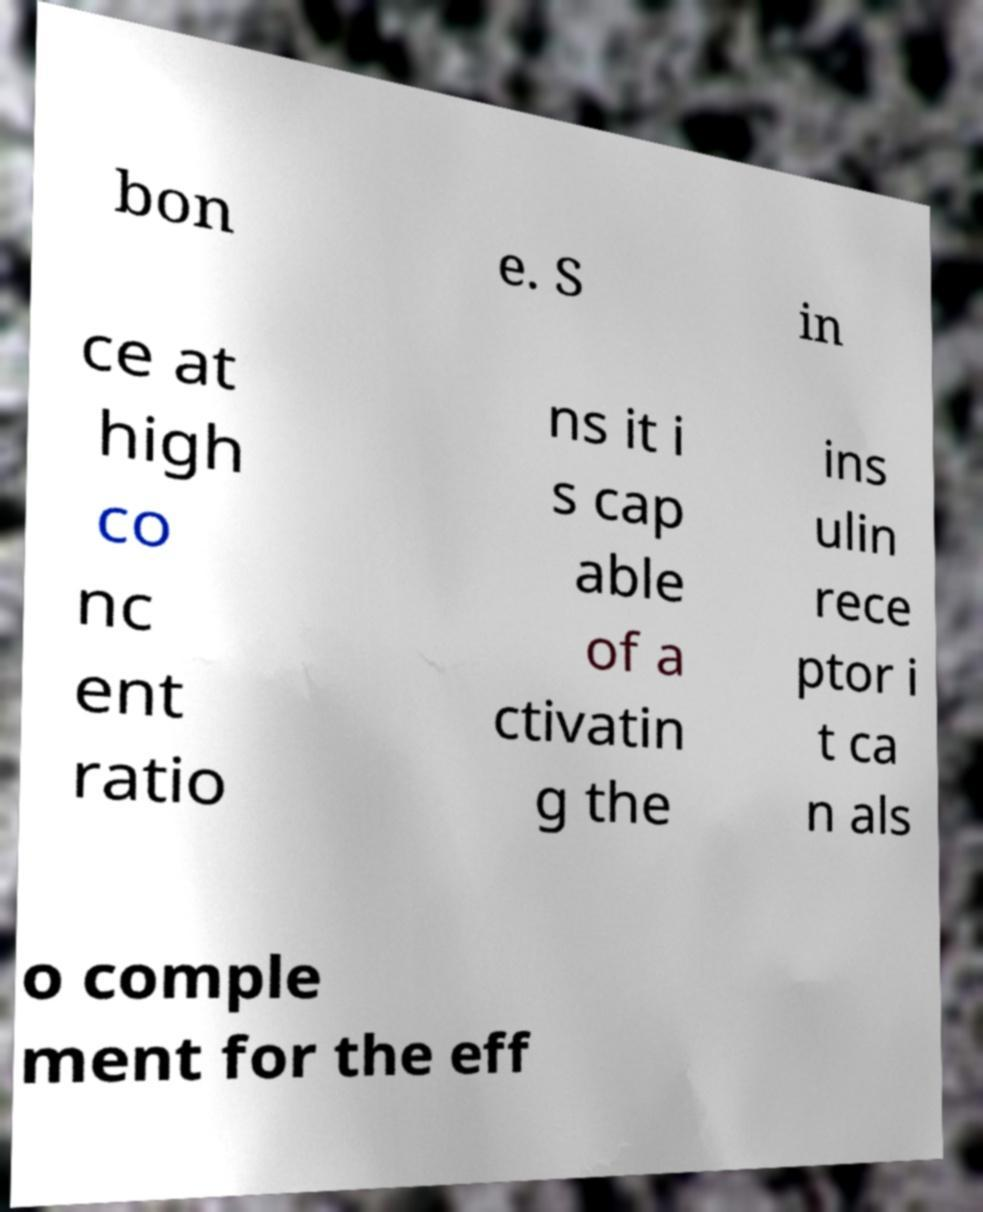I need the written content from this picture converted into text. Can you do that? bon e. S in ce at high co nc ent ratio ns it i s cap able of a ctivatin g the ins ulin rece ptor i t ca n als o comple ment for the eff 